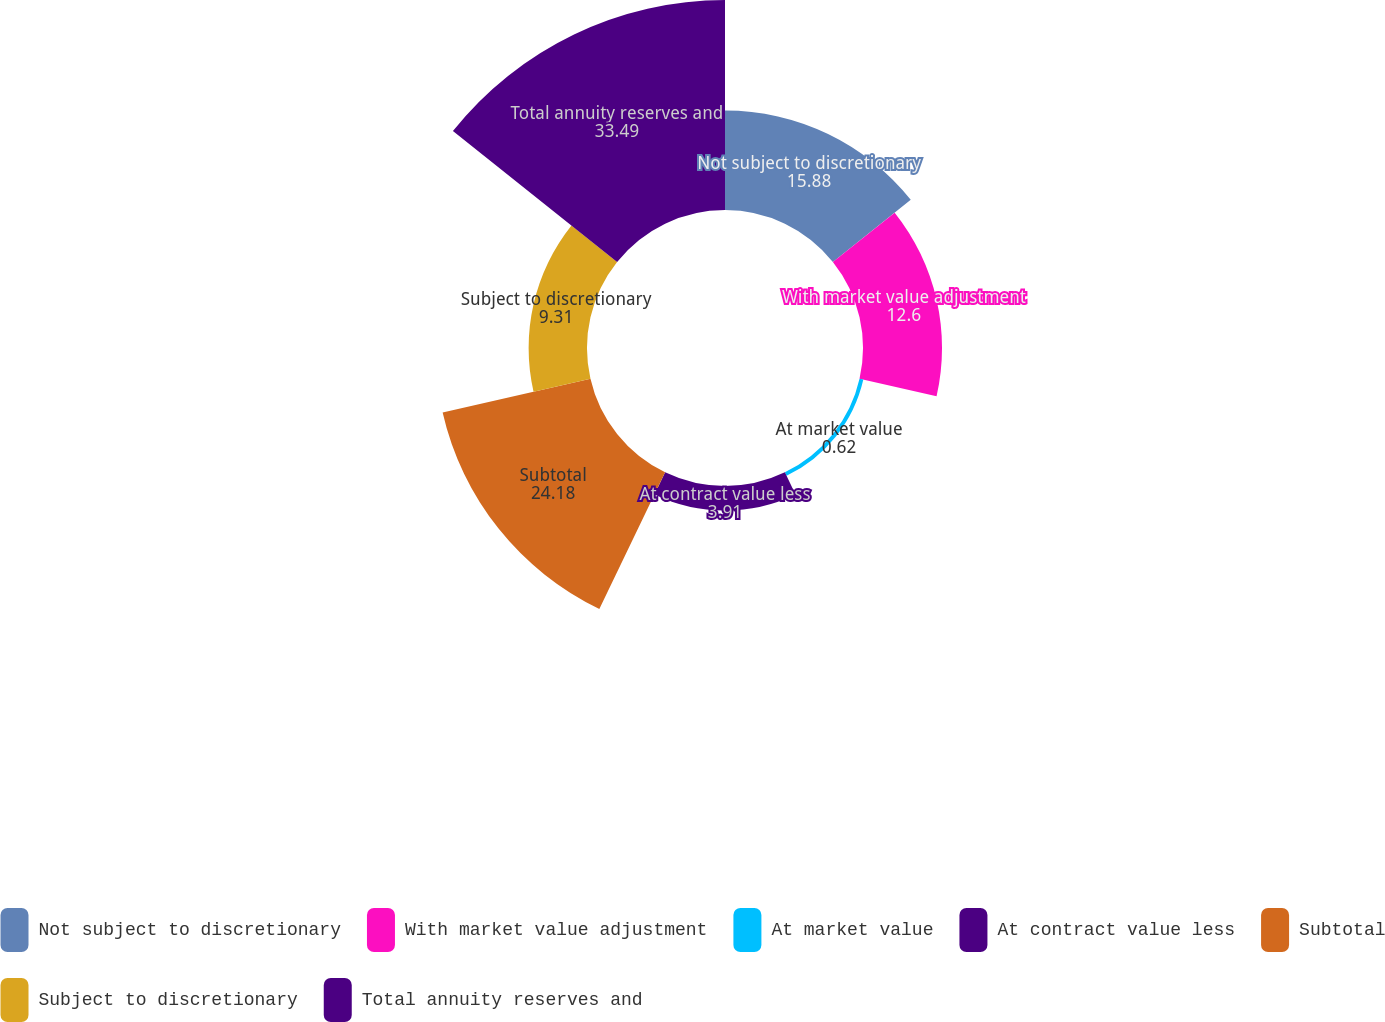Convert chart to OTSL. <chart><loc_0><loc_0><loc_500><loc_500><pie_chart><fcel>Not subject to discretionary<fcel>With market value adjustment<fcel>At market value<fcel>At contract value less<fcel>Subtotal<fcel>Subject to discretionary<fcel>Total annuity reserves and<nl><fcel>15.88%<fcel>12.6%<fcel>0.62%<fcel>3.91%<fcel>24.18%<fcel>9.31%<fcel>33.49%<nl></chart> 